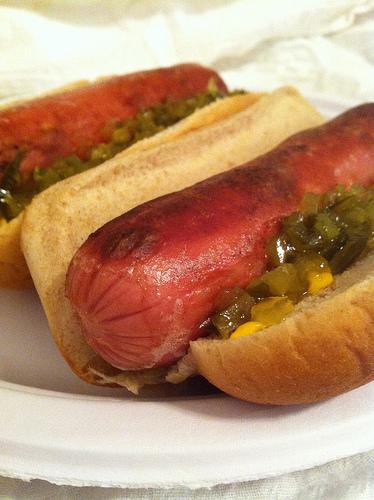Question: what is in the picture?
Choices:
A. Hot dogs.
B. Pizza.
C. Sandwiches.
D. Tacos.
Answer with the letter. Answer: A Question: where are the hot dogs?
Choices:
A. In the fridge.
B. In the oven.
C. On the stove.
D. On plate.
Answer with the letter. Answer: D Question: what color is the plate?
Choices:
A. Green.
B. White.
C. Silver.
D. Black.
Answer with the letter. Answer: B Question: who is eating the hot dogs?
Choices:
A. The woman.
B. The man.
C. The child.
D. No one.
Answer with the letter. Answer: D Question: what color is the mustard?
Choices:
A. Yellow.
B. Brown.
C. Cerise.
D. Orange.
Answer with the letter. Answer: A 